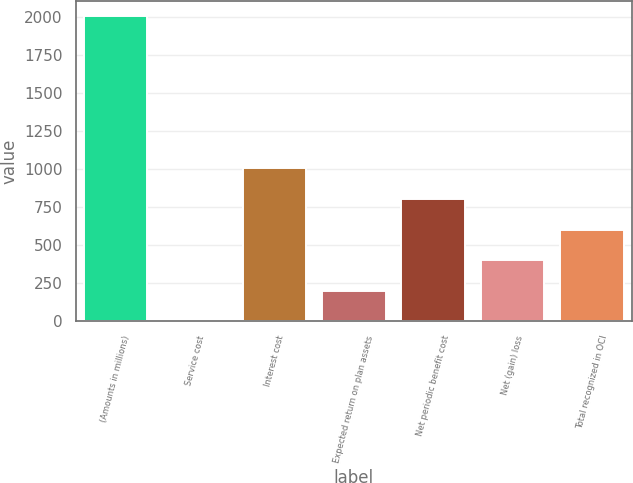Convert chart to OTSL. <chart><loc_0><loc_0><loc_500><loc_500><bar_chart><fcel>(Amounts in millions)<fcel>Service cost<fcel>Interest cost<fcel>Expected return on plan assets<fcel>Net periodic benefit cost<fcel>Net (gain) loss<fcel>Total recognized in OCI<nl><fcel>2010<fcel>0.2<fcel>1005.1<fcel>201.18<fcel>804.12<fcel>402.16<fcel>603.14<nl></chart> 